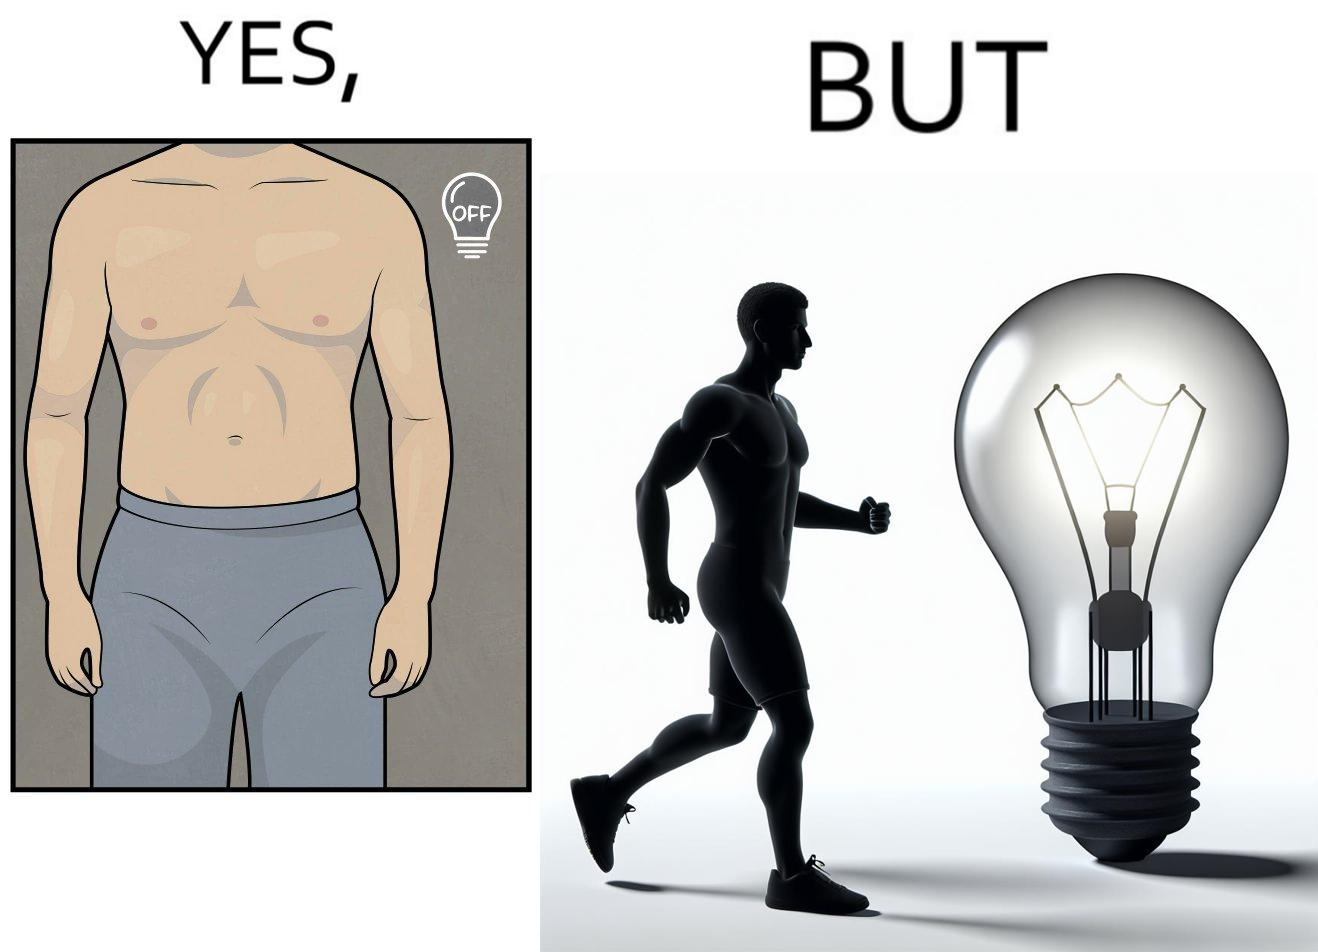Is this image satirical or non-satirical? Yes, this image is satirical. 